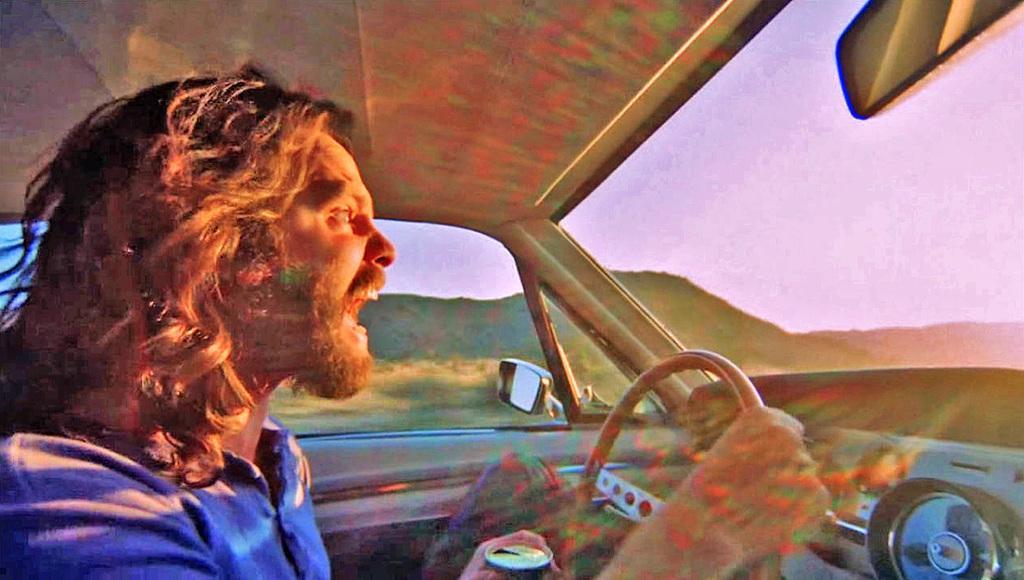Describe this image in one or two sentences. In this image i can see a person driving the car. In the background i can see mountains and the sky. 